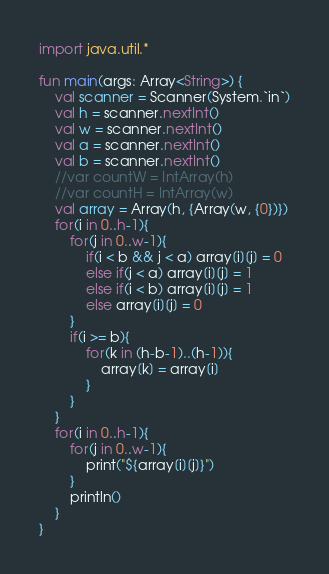<code> <loc_0><loc_0><loc_500><loc_500><_Kotlin_>import java.util.*

fun main(args: Array<String>) {
    val scanner = Scanner(System.`in`)
    val h = scanner.nextInt()
    val w = scanner.nextInt()
    val a = scanner.nextInt()
    val b = scanner.nextInt()
    //var countW = IntArray(h)
    //var countH = IntArray(w)
    val array = Array(h, {Array(w, {0})})
    for(i in 0..h-1){
        for(j in 0..w-1){
            if(i < b && j < a) array[i][j] = 0
            else if(j < a) array[i][j] = 1
            else if(i < b) array[i][j] = 1
            else array[i][j] = 0
        }
        if(i >= b){
            for(k in (h-b-1)..(h-1)){
                array[k] = array[i]
            }
        }
    }
    for(i in 0..h-1){
        for(j in 0..w-1){
            print("${array[i][j]}")
        }
        println()
    }
}</code> 